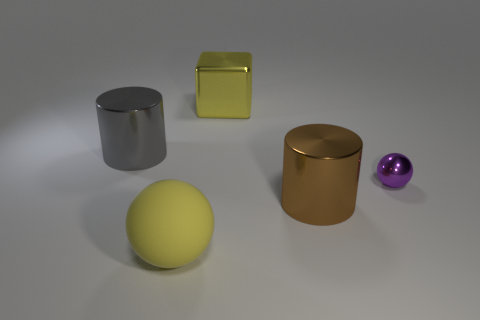Is there any other thing that has the same material as the tiny thing?
Provide a succinct answer. Yes. What size is the purple shiny thing that is the same shape as the large yellow matte object?
Offer a very short reply. Small. There is a large metal thing that is in front of the big yellow metal block and left of the big brown thing; what is its color?
Give a very brief answer. Gray. Is the gray cylinder made of the same material as the large yellow thing on the right side of the yellow matte thing?
Offer a very short reply. Yes. Are there fewer balls right of the large yellow rubber thing than big brown cylinders?
Offer a terse response. No. What number of other objects are there of the same shape as the small metallic thing?
Keep it short and to the point. 1. Are there any other things of the same color as the small ball?
Keep it short and to the point. No. There is a metallic block; does it have the same color as the sphere that is left of the large metal block?
Give a very brief answer. Yes. What number of other objects are there of the same size as the metal sphere?
Give a very brief answer. 0. There is a block that is the same color as the large rubber object; what is its size?
Keep it short and to the point. Large. 